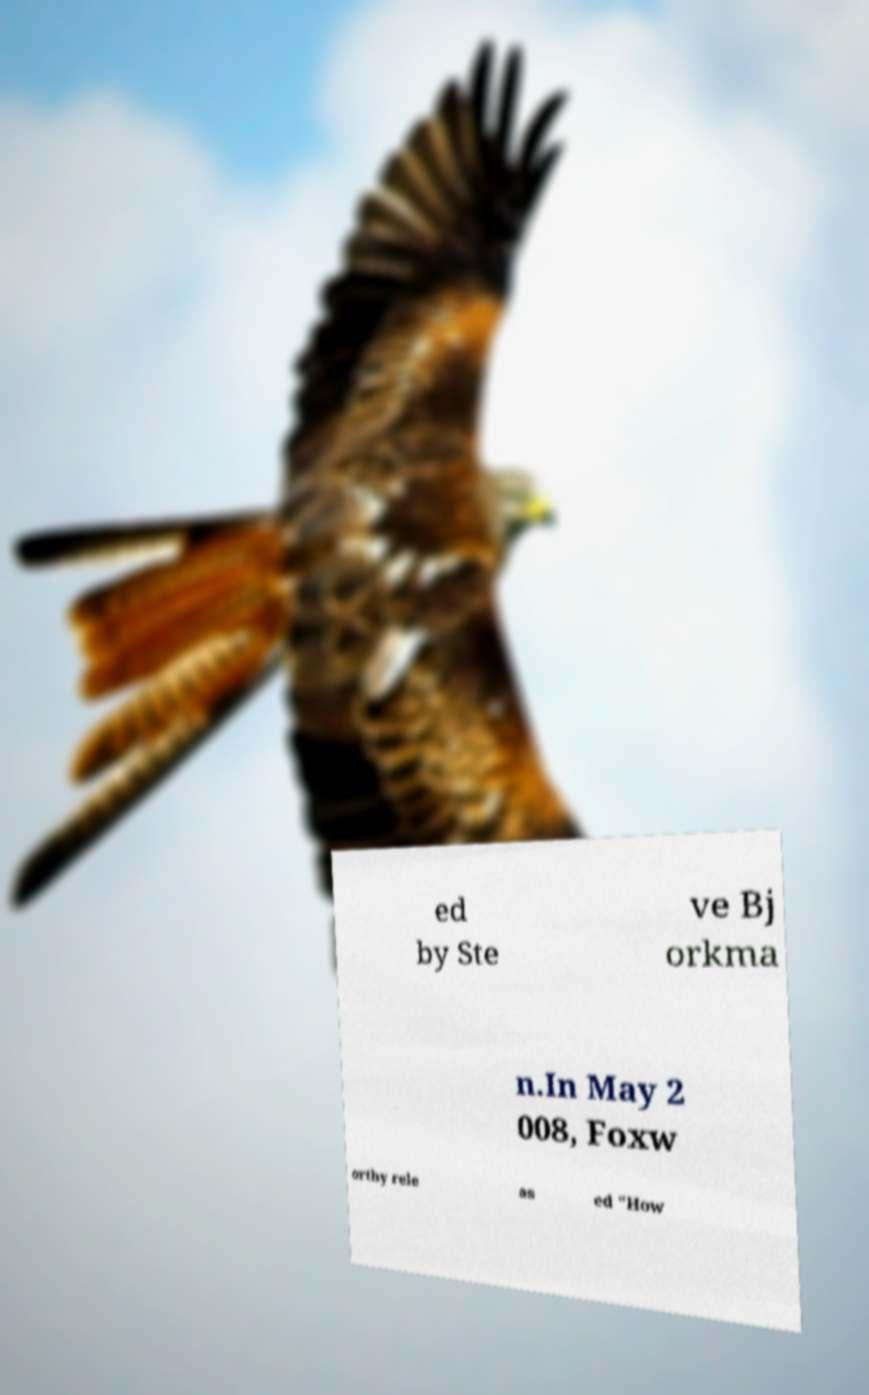Please identify and transcribe the text found in this image. ed by Ste ve Bj orkma n.In May 2 008, Foxw orthy rele as ed "How 